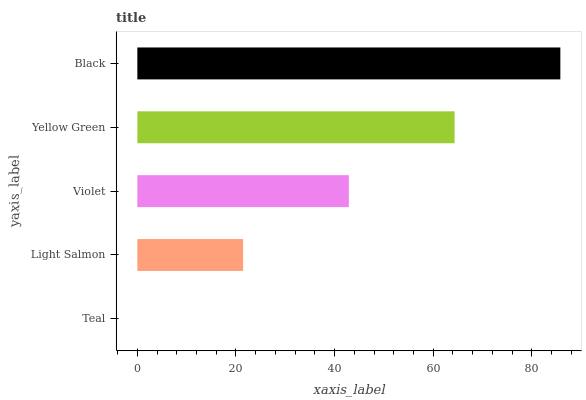Is Teal the minimum?
Answer yes or no. Yes. Is Black the maximum?
Answer yes or no. Yes. Is Light Salmon the minimum?
Answer yes or no. No. Is Light Salmon the maximum?
Answer yes or no. No. Is Light Salmon greater than Teal?
Answer yes or no. Yes. Is Teal less than Light Salmon?
Answer yes or no. Yes. Is Teal greater than Light Salmon?
Answer yes or no. No. Is Light Salmon less than Teal?
Answer yes or no. No. Is Violet the high median?
Answer yes or no. Yes. Is Violet the low median?
Answer yes or no. Yes. Is Yellow Green the high median?
Answer yes or no. No. Is Light Salmon the low median?
Answer yes or no. No. 